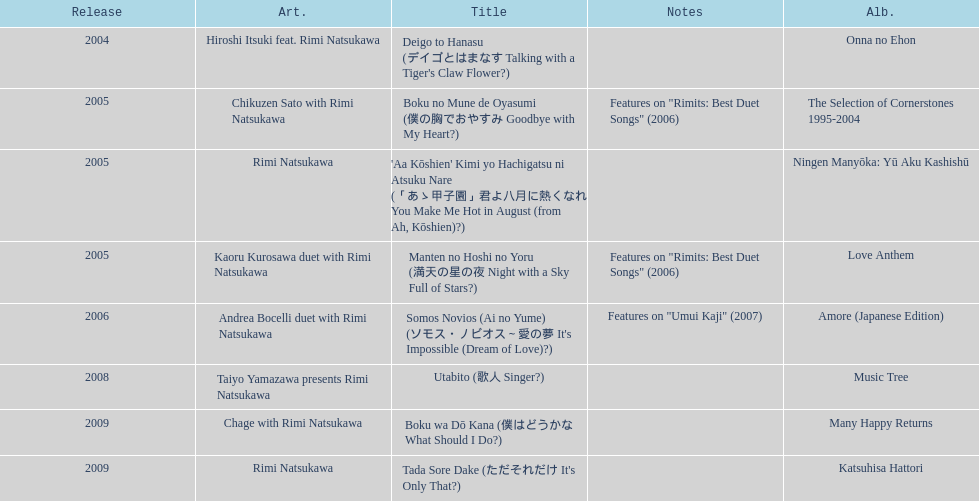What year was the first title released? 2004. 